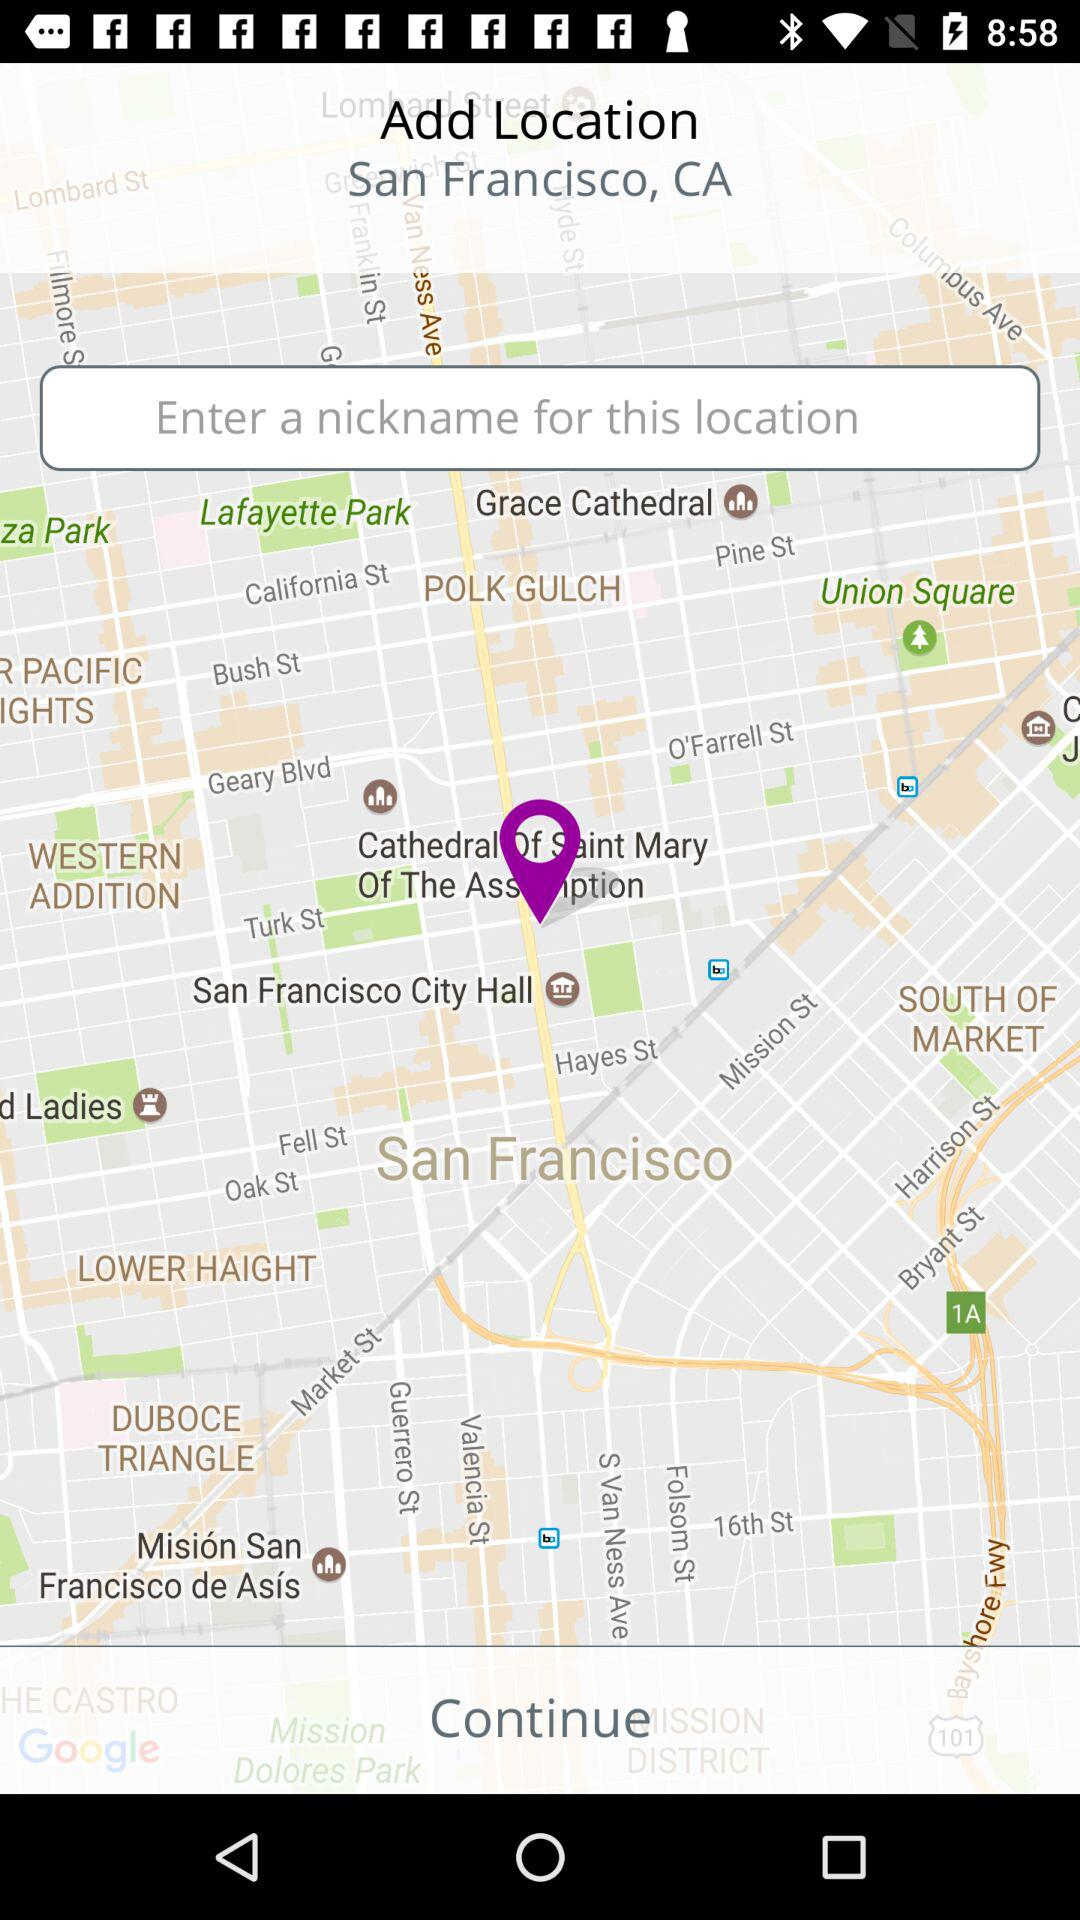How many text inputs are on the screen?
Answer the question using a single word or phrase. 1 